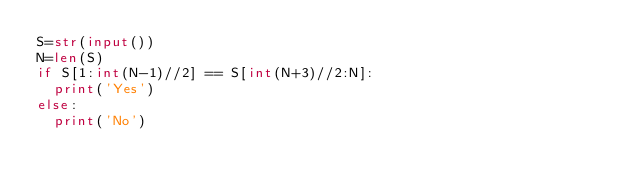<code> <loc_0><loc_0><loc_500><loc_500><_Python_>S=str(input())
N=len(S)
if S[1:int(N-1)//2] == S[int(N+3)//2:N]:
  print('Yes')
else:
  print('No')
</code> 